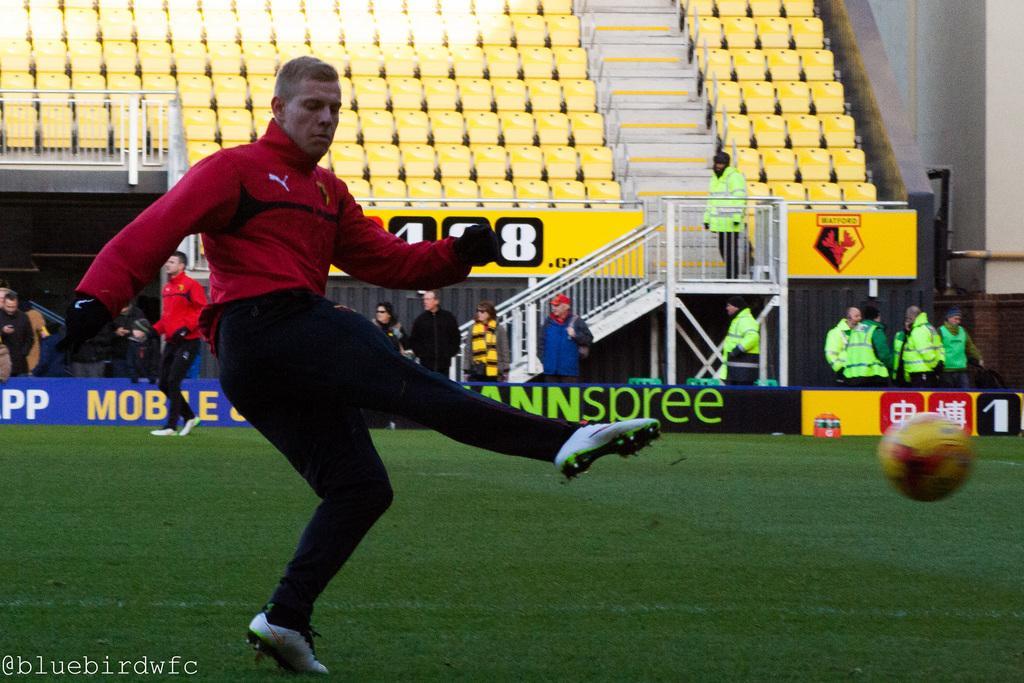Describe this image in one or two sentences. In this picture we can see a man in the red jacket is in motion and in front of the man there is a ball. Behind the man there are groups of people standing, steel fence and chairs and on the image there is a watermark. 